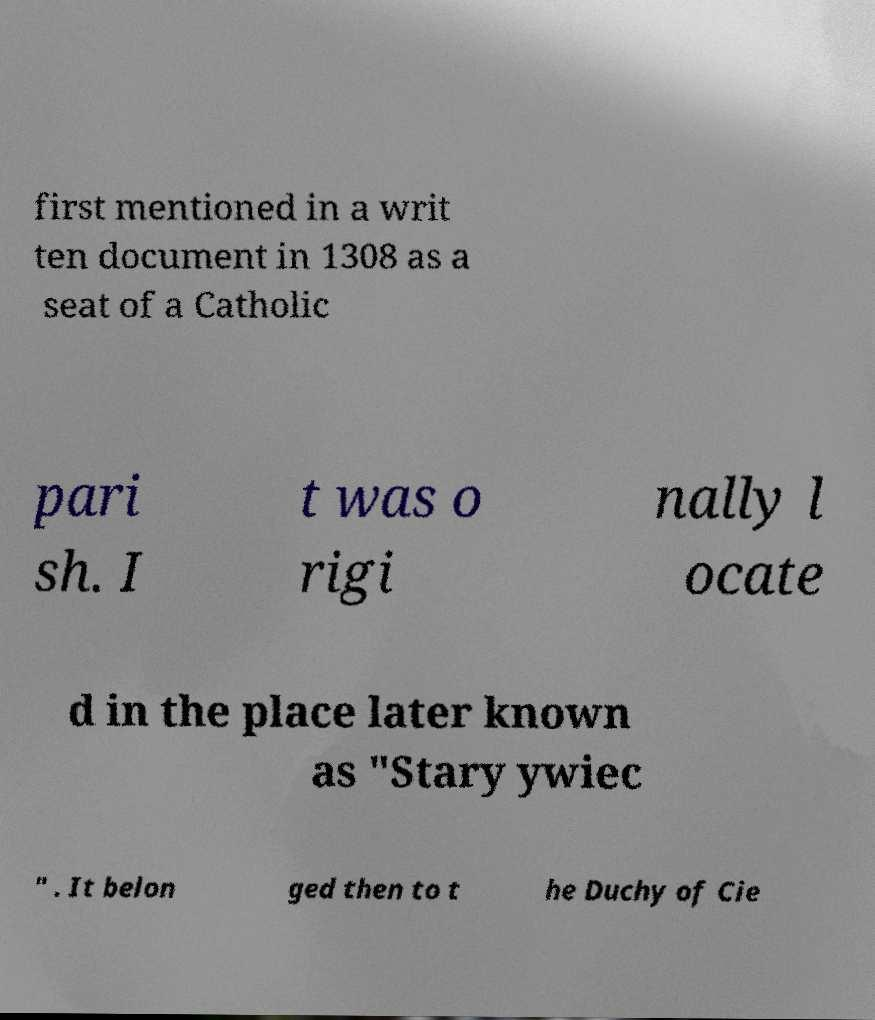I need the written content from this picture converted into text. Can you do that? first mentioned in a writ ten document in 1308 as a seat of a Catholic pari sh. I t was o rigi nally l ocate d in the place later known as "Stary ywiec " . It belon ged then to t he Duchy of Cie 